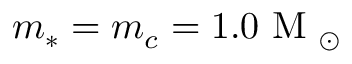Convert formula to latex. <formula><loc_0><loc_0><loc_500><loc_500>m _ { * } = m _ { c } = 1 . 0 M _ { \odot }</formula> 